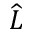<formula> <loc_0><loc_0><loc_500><loc_500>\widehat { L }</formula> 